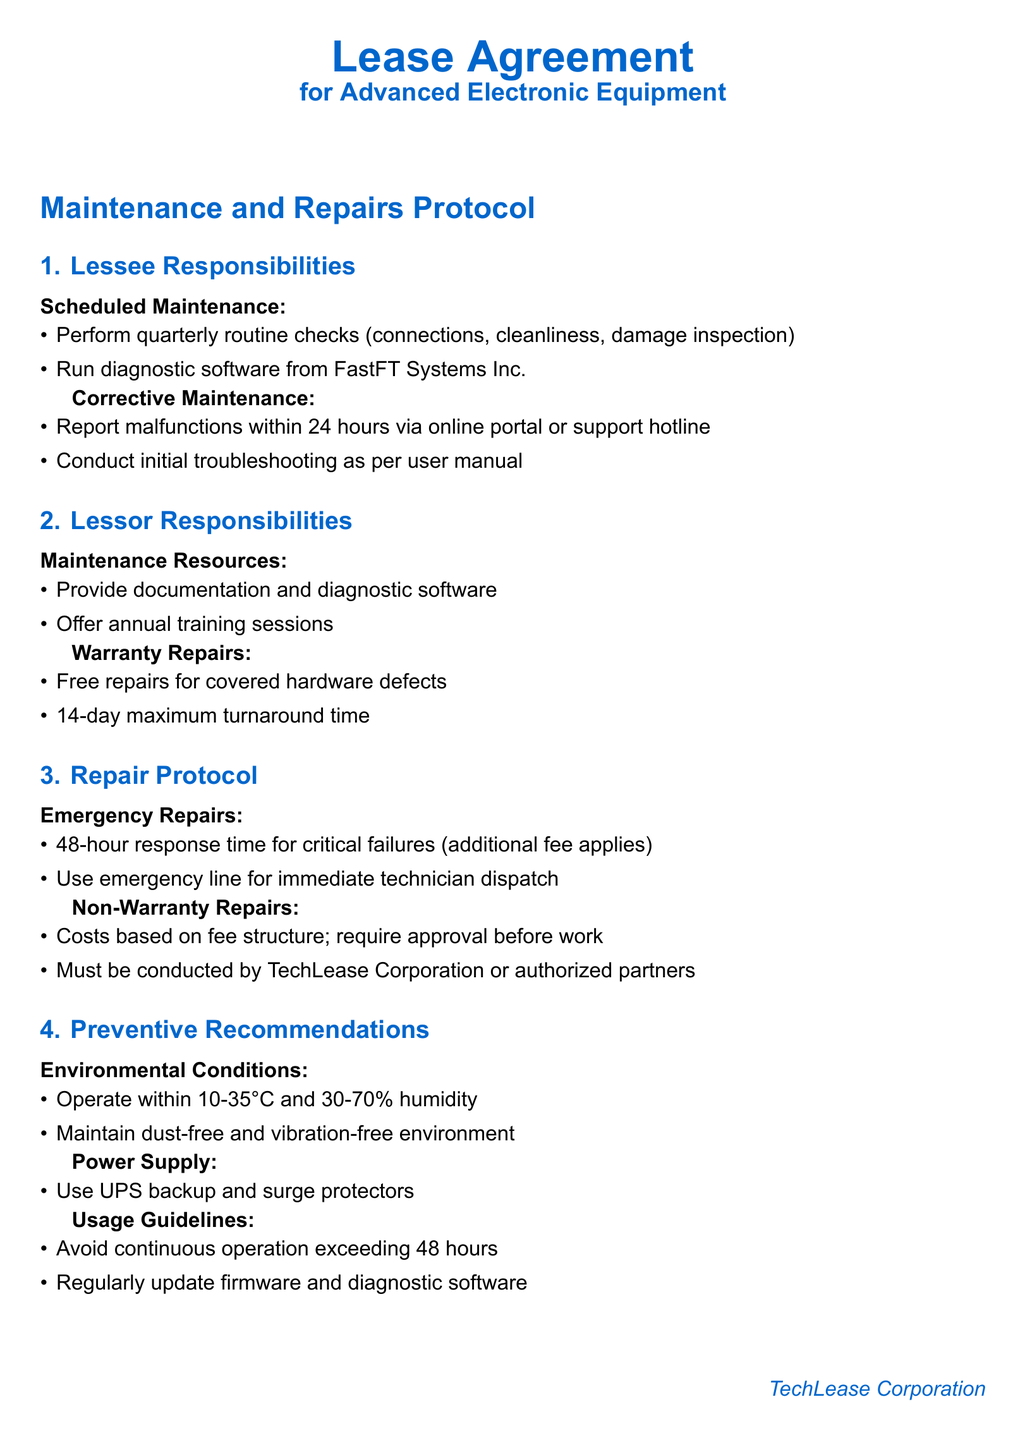What is the frequency of scheduled maintenance? The document states that scheduled maintenance should be performed quarterly.
Answer: quarterly What is the maximum turnaround time for warranty repairs? According to the document, the maximum turnaround time for warranty repairs is 14 days.
Answer: 14 days What should be used for emergency repair response? The document specifies using an emergency line for immediate technician dispatch.
Answer: emergency line What temperature range is recommended for operation? The document recommends operating within a temperature range of 10 to 35 degrees Celsius.
Answer: 10-35°C What action should be taken upon detecting a malfunction? The document indicates that a malfunction should be reported within 24 hours.
Answer: 24 hours What is required before conducting non-warranty repairs? The document states that approval is required before work for non-warranty repairs.
Answer: approval What percentage of humidity is advised for equipment operation? The document advises maintaining humidity at 30 to 70 percent.
Answer: 30-70% Who provides annual training sessions? The lessor is responsible for providing annual training sessions, as stated in the document.
Answer: lessor 